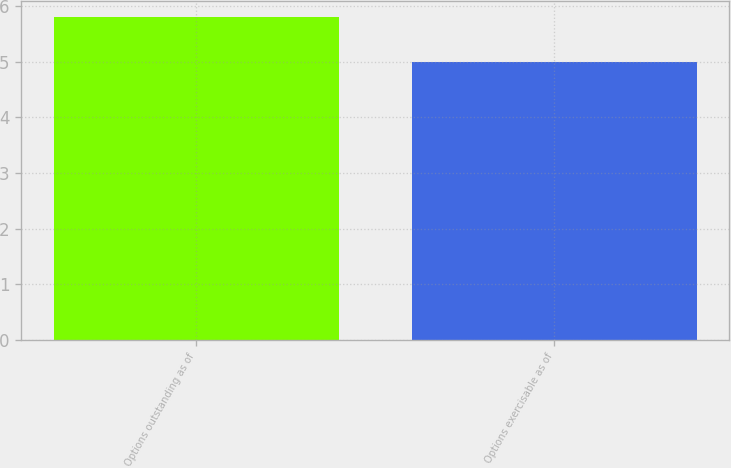Convert chart to OTSL. <chart><loc_0><loc_0><loc_500><loc_500><bar_chart><fcel>Options outstanding as of<fcel>Options exercisable as of<nl><fcel>5.8<fcel>5<nl></chart> 